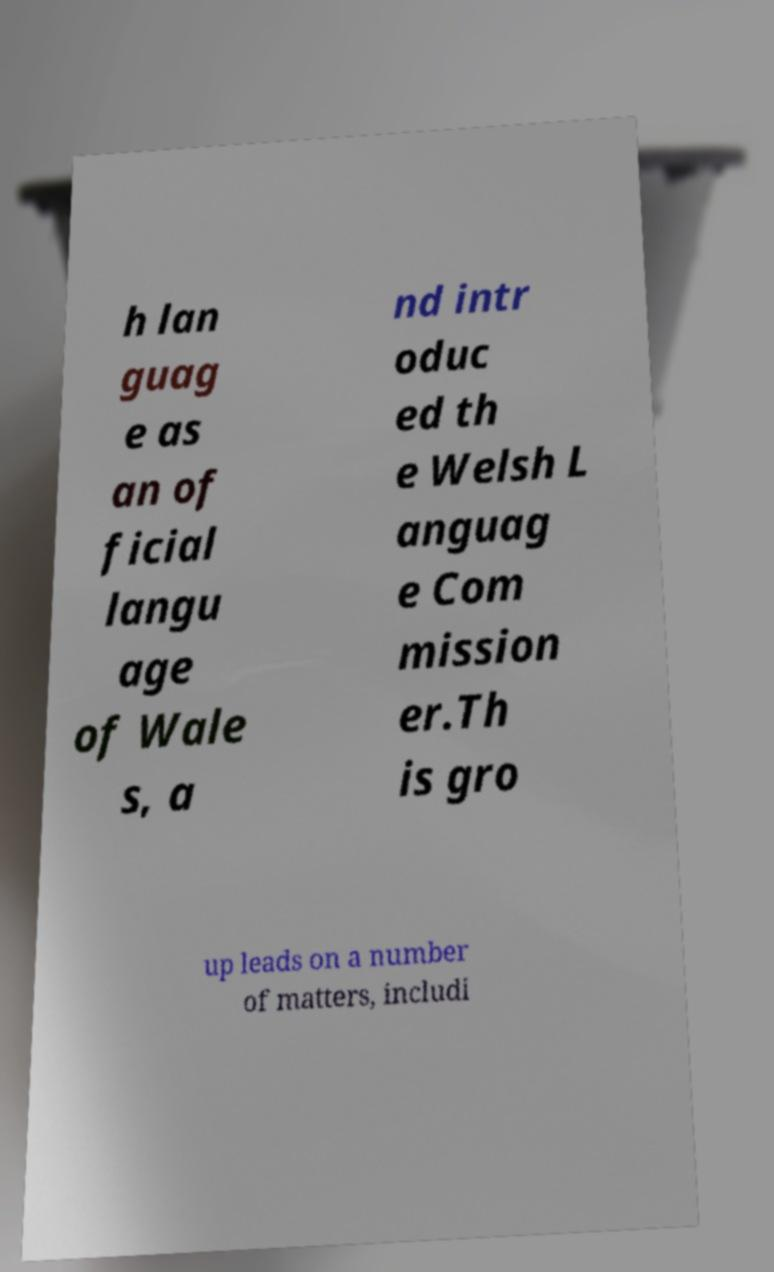Can you read and provide the text displayed in the image?This photo seems to have some interesting text. Can you extract and type it out for me? h lan guag e as an of ficial langu age of Wale s, a nd intr oduc ed th e Welsh L anguag e Com mission er.Th is gro up leads on a number of matters, includi 